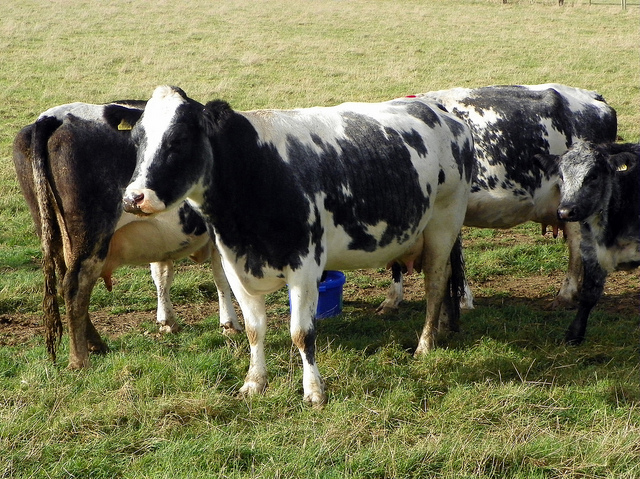What breed might these cows be, based on their markings? Based on their black and white markings, these cows could possibly be of the Holstein breed, which is known for its dairy production and distinctive color patterns. 